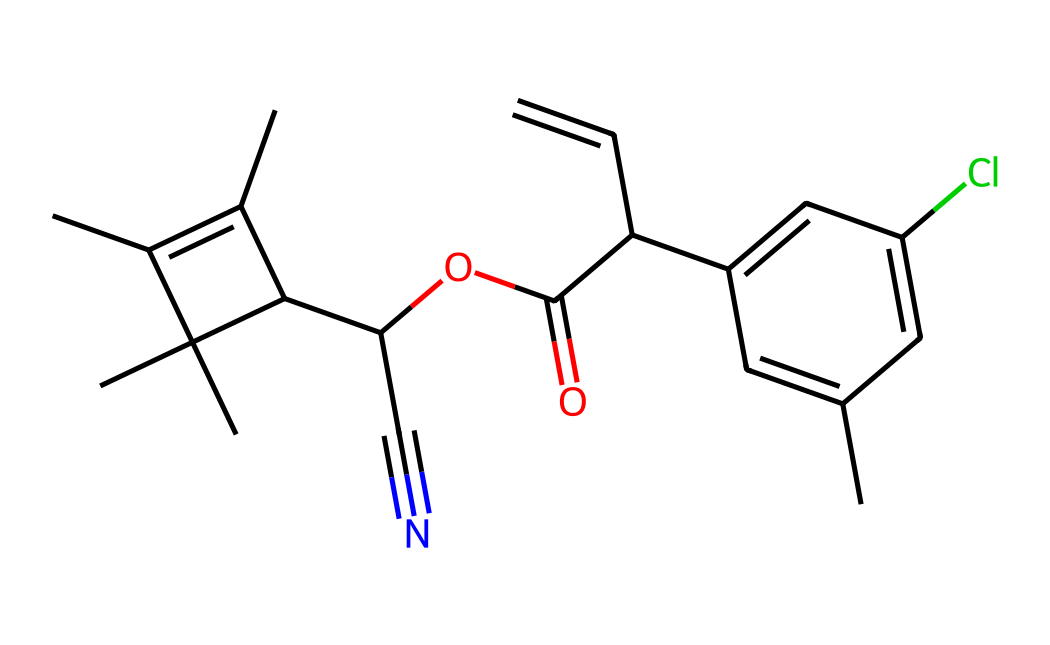What is the molecular formula of permethrin? To determine the molecular formula, we analyze the provided SMILES representation, counting each type of atom. The structure contains carbon (C), hydrogen (H), oxygen (O), and chlorine (Cl) atoms. The total count from the SMILES is 21 carbon atoms, 22 hydrogen atoms, 2 oxygen atoms, and 1 chlorine atom, leading to the formula C21H22Cl2O2.
Answer: C21H22Cl2O2 How many benzene rings are present in the structure? In the SMILES representation, there are two cyclic structures that resemble benzene due to the presence of alternating double bonds. By tracing the structure, we can identify that two aromatic rings are part of the overall structure.
Answer: 2 What type of chemical is permethrin classified as? By examining the functional groups and structure in the SMILES notation, we see that permethrin is a synthetic pyrethroid, known for its insecticidal properties. The presence of specific functional groups indicates that it acts similarly to natural pyrethrins.
Answer: pyrethroid Does permethrin contain any halogen atoms? By reviewing the SMILES representation, we can spot the presence of a chlorine atom, a common halogen in many chemical structures. This is confirmed by identifying 'Cl' in the molecular formula derived from the SMILES.
Answer: yes What is a notable functional group found in permethrin? By analyzing the structure from the SMILES, we can identify the ester functional group indicated by the presence of ‘C(=O)O’. This functional group plays a key role in the chemical's properties and reactivity.
Answer: ester How many chiral centers does permethrin have? Investigating the structure reveals that there are two carbon atoms that are bonded to four different substituents, indicating the presence of chiral centers. This can be confirmed visually by drawing the structure or reasoning based on the atom connectivity from the SMILES.
Answer: 2 